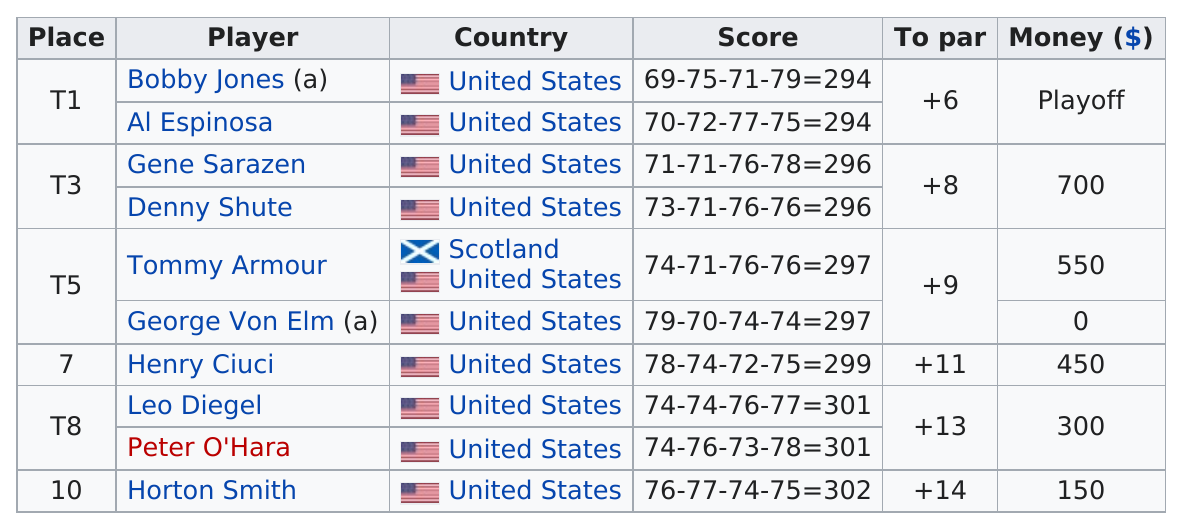Indicate a few pertinent items in this graphic. The person who finished in last place was from the United States. Tommy Armour, a professional golfer from Scotland, is one of the players representing countries other than America in the golf tournament. Thirty-three percent of the players who scored a plus ten or better in their round were players. Bobby Jones and Al Espinosa tied for first place in a competition. Bobby Jones and Al Espinosa were followed by Gene Sarazen and Denny Shute in finishing second place. 